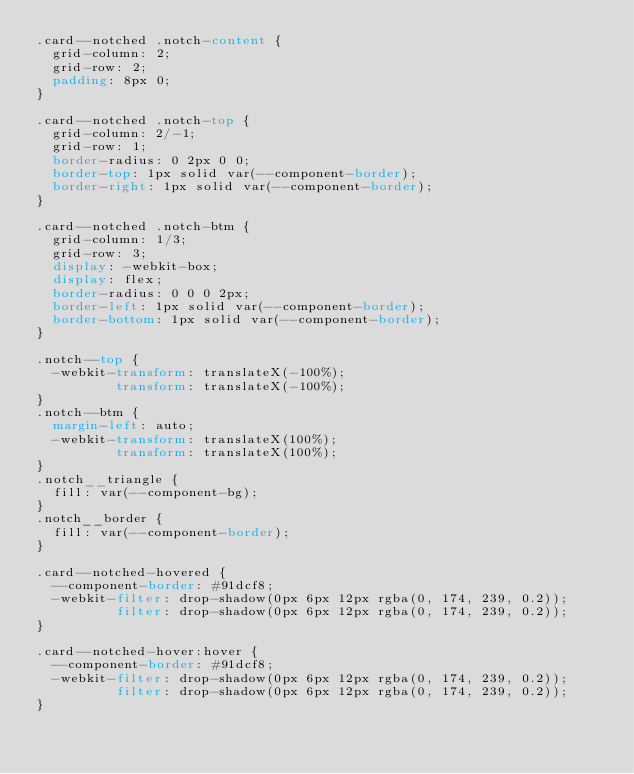Convert code to text. <code><loc_0><loc_0><loc_500><loc_500><_CSS_>.card--notched .notch-content {
  grid-column: 2;
  grid-row: 2;
  padding: 8px 0;
}

.card--notched .notch-top {
  grid-column: 2/-1;
  grid-row: 1;
  border-radius: 0 2px 0 0;
  border-top: 1px solid var(--component-border);
  border-right: 1px solid var(--component-border);
}

.card--notched .notch-btm {
  grid-column: 1/3;
  grid-row: 3;
  display: -webkit-box;
  display: flex;
  border-radius: 0 0 0 2px;
  border-left: 1px solid var(--component-border);
  border-bottom: 1px solid var(--component-border);
}

.notch--top {
  -webkit-transform: translateX(-100%);
          transform: translateX(-100%);
}
.notch--btm {
  margin-left: auto;
  -webkit-transform: translateX(100%);
          transform: translateX(100%);
}
.notch__triangle {
  fill: var(--component-bg);
}
.notch__border {
  fill: var(--component-border);
}

.card--notched-hovered {
  --component-border: #91dcf8;
  -webkit-filter: drop-shadow(0px 6px 12px rgba(0, 174, 239, 0.2));
          filter: drop-shadow(0px 6px 12px rgba(0, 174, 239, 0.2));
}

.card--notched-hover:hover {
  --component-border: #91dcf8;
  -webkit-filter: drop-shadow(0px 6px 12px rgba(0, 174, 239, 0.2));
          filter: drop-shadow(0px 6px 12px rgba(0, 174, 239, 0.2));
}
</code> 